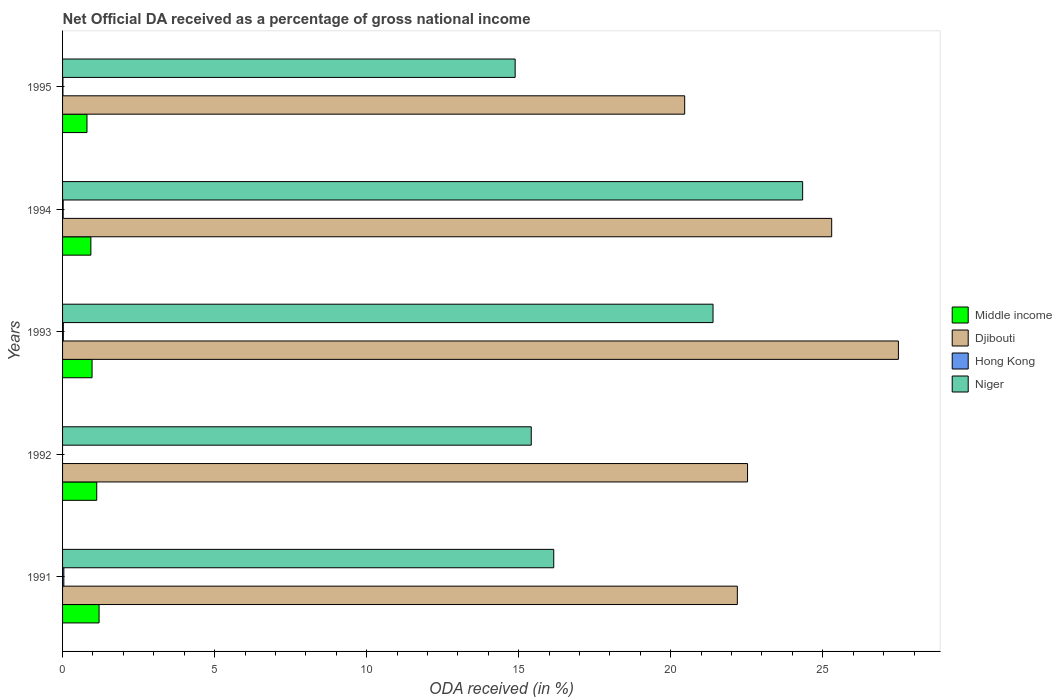How many different coloured bars are there?
Ensure brevity in your answer.  4. How many groups of bars are there?
Your response must be concise. 5. Are the number of bars per tick equal to the number of legend labels?
Provide a succinct answer. No. Are the number of bars on each tick of the Y-axis equal?
Your answer should be compact. No. How many bars are there on the 1st tick from the bottom?
Offer a very short reply. 4. In how many cases, is the number of bars for a given year not equal to the number of legend labels?
Make the answer very short. 1. What is the net official DA received in Middle income in 1993?
Provide a short and direct response. 0.97. Across all years, what is the maximum net official DA received in Djibouti?
Provide a succinct answer. 27.49. Across all years, what is the minimum net official DA received in Djibouti?
Keep it short and to the point. 20.46. What is the total net official DA received in Djibouti in the graph?
Keep it short and to the point. 117.95. What is the difference between the net official DA received in Hong Kong in 1994 and that in 1995?
Provide a succinct answer. 0.01. What is the difference between the net official DA received in Niger in 1992 and the net official DA received in Djibouti in 1991?
Your answer should be compact. -6.78. What is the average net official DA received in Niger per year?
Keep it short and to the point. 18.44. In the year 1995, what is the difference between the net official DA received in Niger and net official DA received in Djibouti?
Your answer should be compact. -5.58. In how many years, is the net official DA received in Niger greater than 5 %?
Your answer should be compact. 5. What is the ratio of the net official DA received in Hong Kong in 1993 to that in 1995?
Keep it short and to the point. 2.06. What is the difference between the highest and the second highest net official DA received in Djibouti?
Ensure brevity in your answer.  2.19. What is the difference between the highest and the lowest net official DA received in Middle income?
Your response must be concise. 0.4. In how many years, is the net official DA received in Niger greater than the average net official DA received in Niger taken over all years?
Give a very brief answer. 2. Is it the case that in every year, the sum of the net official DA received in Niger and net official DA received in Djibouti is greater than the sum of net official DA received in Middle income and net official DA received in Hong Kong?
Keep it short and to the point. No. What is the difference between two consecutive major ticks on the X-axis?
Keep it short and to the point. 5. Are the values on the major ticks of X-axis written in scientific E-notation?
Ensure brevity in your answer.  No. Does the graph contain grids?
Your response must be concise. No. Where does the legend appear in the graph?
Your response must be concise. Center right. How many legend labels are there?
Give a very brief answer. 4. What is the title of the graph?
Provide a short and direct response. Net Official DA received as a percentage of gross national income. What is the label or title of the X-axis?
Provide a short and direct response. ODA received (in %). What is the ODA received (in %) of Middle income in 1991?
Provide a succinct answer. 1.2. What is the ODA received (in %) of Djibouti in 1991?
Give a very brief answer. 22.19. What is the ODA received (in %) in Hong Kong in 1991?
Your response must be concise. 0.04. What is the ODA received (in %) of Niger in 1991?
Your answer should be compact. 16.15. What is the ODA received (in %) in Middle income in 1992?
Ensure brevity in your answer.  1.12. What is the ODA received (in %) of Djibouti in 1992?
Keep it short and to the point. 22.53. What is the ODA received (in %) in Hong Kong in 1992?
Provide a succinct answer. 0. What is the ODA received (in %) of Niger in 1992?
Ensure brevity in your answer.  15.41. What is the ODA received (in %) in Middle income in 1993?
Offer a very short reply. 0.97. What is the ODA received (in %) in Djibouti in 1993?
Offer a terse response. 27.49. What is the ODA received (in %) in Hong Kong in 1993?
Your answer should be compact. 0.03. What is the ODA received (in %) in Niger in 1993?
Provide a succinct answer. 21.39. What is the ODA received (in %) in Middle income in 1994?
Ensure brevity in your answer.  0.93. What is the ODA received (in %) in Djibouti in 1994?
Ensure brevity in your answer.  25.29. What is the ODA received (in %) of Hong Kong in 1994?
Give a very brief answer. 0.02. What is the ODA received (in %) of Niger in 1994?
Your answer should be compact. 24.34. What is the ODA received (in %) of Middle income in 1995?
Your answer should be compact. 0.8. What is the ODA received (in %) in Djibouti in 1995?
Offer a terse response. 20.46. What is the ODA received (in %) of Hong Kong in 1995?
Your answer should be compact. 0.01. What is the ODA received (in %) in Niger in 1995?
Keep it short and to the point. 14.88. Across all years, what is the maximum ODA received (in %) in Middle income?
Make the answer very short. 1.2. Across all years, what is the maximum ODA received (in %) of Djibouti?
Provide a short and direct response. 27.49. Across all years, what is the maximum ODA received (in %) of Hong Kong?
Your response must be concise. 0.04. Across all years, what is the maximum ODA received (in %) of Niger?
Provide a short and direct response. 24.34. Across all years, what is the minimum ODA received (in %) of Middle income?
Keep it short and to the point. 0.8. Across all years, what is the minimum ODA received (in %) in Djibouti?
Your answer should be compact. 20.46. Across all years, what is the minimum ODA received (in %) in Hong Kong?
Your answer should be very brief. 0. Across all years, what is the minimum ODA received (in %) in Niger?
Your answer should be compact. 14.88. What is the total ODA received (in %) in Middle income in the graph?
Keep it short and to the point. 5.03. What is the total ODA received (in %) in Djibouti in the graph?
Give a very brief answer. 117.95. What is the total ODA received (in %) of Hong Kong in the graph?
Ensure brevity in your answer.  0.1. What is the total ODA received (in %) in Niger in the graph?
Offer a terse response. 92.18. What is the difference between the ODA received (in %) of Middle income in 1991 and that in 1992?
Offer a very short reply. 0.08. What is the difference between the ODA received (in %) in Djibouti in 1991 and that in 1992?
Ensure brevity in your answer.  -0.34. What is the difference between the ODA received (in %) in Niger in 1991 and that in 1992?
Your answer should be very brief. 0.74. What is the difference between the ODA received (in %) in Middle income in 1991 and that in 1993?
Make the answer very short. 0.23. What is the difference between the ODA received (in %) of Djibouti in 1991 and that in 1993?
Keep it short and to the point. -5.3. What is the difference between the ODA received (in %) of Hong Kong in 1991 and that in 1993?
Ensure brevity in your answer.  0.02. What is the difference between the ODA received (in %) of Niger in 1991 and that in 1993?
Your answer should be compact. -5.24. What is the difference between the ODA received (in %) of Middle income in 1991 and that in 1994?
Offer a terse response. 0.27. What is the difference between the ODA received (in %) in Djibouti in 1991 and that in 1994?
Offer a terse response. -3.1. What is the difference between the ODA received (in %) in Hong Kong in 1991 and that in 1994?
Provide a succinct answer. 0.02. What is the difference between the ODA received (in %) in Niger in 1991 and that in 1994?
Your response must be concise. -8.18. What is the difference between the ODA received (in %) of Middle income in 1991 and that in 1995?
Your answer should be very brief. 0.4. What is the difference between the ODA received (in %) of Djibouti in 1991 and that in 1995?
Offer a very short reply. 1.73. What is the difference between the ODA received (in %) of Hong Kong in 1991 and that in 1995?
Provide a succinct answer. 0.03. What is the difference between the ODA received (in %) in Niger in 1991 and that in 1995?
Provide a succinct answer. 1.27. What is the difference between the ODA received (in %) in Middle income in 1992 and that in 1993?
Provide a succinct answer. 0.15. What is the difference between the ODA received (in %) in Djibouti in 1992 and that in 1993?
Offer a very short reply. -4.96. What is the difference between the ODA received (in %) of Niger in 1992 and that in 1993?
Make the answer very short. -5.98. What is the difference between the ODA received (in %) of Middle income in 1992 and that in 1994?
Your response must be concise. 0.19. What is the difference between the ODA received (in %) of Djibouti in 1992 and that in 1994?
Keep it short and to the point. -2.77. What is the difference between the ODA received (in %) in Niger in 1992 and that in 1994?
Offer a terse response. -8.92. What is the difference between the ODA received (in %) in Middle income in 1992 and that in 1995?
Give a very brief answer. 0.32. What is the difference between the ODA received (in %) in Djibouti in 1992 and that in 1995?
Provide a succinct answer. 2.07. What is the difference between the ODA received (in %) of Niger in 1992 and that in 1995?
Make the answer very short. 0.53. What is the difference between the ODA received (in %) in Middle income in 1993 and that in 1994?
Keep it short and to the point. 0.04. What is the difference between the ODA received (in %) of Djibouti in 1993 and that in 1994?
Ensure brevity in your answer.  2.19. What is the difference between the ODA received (in %) in Hong Kong in 1993 and that in 1994?
Ensure brevity in your answer.  0.01. What is the difference between the ODA received (in %) of Niger in 1993 and that in 1994?
Your answer should be compact. -2.95. What is the difference between the ODA received (in %) in Middle income in 1993 and that in 1995?
Provide a succinct answer. 0.17. What is the difference between the ODA received (in %) in Djibouti in 1993 and that in 1995?
Your answer should be very brief. 7.03. What is the difference between the ODA received (in %) of Hong Kong in 1993 and that in 1995?
Provide a succinct answer. 0.01. What is the difference between the ODA received (in %) in Niger in 1993 and that in 1995?
Your answer should be compact. 6.51. What is the difference between the ODA received (in %) in Middle income in 1994 and that in 1995?
Offer a terse response. 0.13. What is the difference between the ODA received (in %) of Djibouti in 1994 and that in 1995?
Give a very brief answer. 4.83. What is the difference between the ODA received (in %) of Hong Kong in 1994 and that in 1995?
Give a very brief answer. 0.01. What is the difference between the ODA received (in %) of Niger in 1994 and that in 1995?
Offer a very short reply. 9.45. What is the difference between the ODA received (in %) of Middle income in 1991 and the ODA received (in %) of Djibouti in 1992?
Your answer should be very brief. -21.33. What is the difference between the ODA received (in %) of Middle income in 1991 and the ODA received (in %) of Niger in 1992?
Your response must be concise. -14.21. What is the difference between the ODA received (in %) of Djibouti in 1991 and the ODA received (in %) of Niger in 1992?
Your answer should be compact. 6.78. What is the difference between the ODA received (in %) in Hong Kong in 1991 and the ODA received (in %) in Niger in 1992?
Give a very brief answer. -15.37. What is the difference between the ODA received (in %) of Middle income in 1991 and the ODA received (in %) of Djibouti in 1993?
Offer a very short reply. -26.29. What is the difference between the ODA received (in %) of Middle income in 1991 and the ODA received (in %) of Hong Kong in 1993?
Your response must be concise. 1.18. What is the difference between the ODA received (in %) of Middle income in 1991 and the ODA received (in %) of Niger in 1993?
Provide a succinct answer. -20.19. What is the difference between the ODA received (in %) in Djibouti in 1991 and the ODA received (in %) in Hong Kong in 1993?
Offer a terse response. 22.17. What is the difference between the ODA received (in %) of Djibouti in 1991 and the ODA received (in %) of Niger in 1993?
Your answer should be very brief. 0.8. What is the difference between the ODA received (in %) of Hong Kong in 1991 and the ODA received (in %) of Niger in 1993?
Give a very brief answer. -21.35. What is the difference between the ODA received (in %) in Middle income in 1991 and the ODA received (in %) in Djibouti in 1994?
Your response must be concise. -24.09. What is the difference between the ODA received (in %) of Middle income in 1991 and the ODA received (in %) of Hong Kong in 1994?
Make the answer very short. 1.18. What is the difference between the ODA received (in %) in Middle income in 1991 and the ODA received (in %) in Niger in 1994?
Make the answer very short. -23.14. What is the difference between the ODA received (in %) in Djibouti in 1991 and the ODA received (in %) in Hong Kong in 1994?
Your answer should be compact. 22.17. What is the difference between the ODA received (in %) of Djibouti in 1991 and the ODA received (in %) of Niger in 1994?
Provide a succinct answer. -2.15. What is the difference between the ODA received (in %) in Hong Kong in 1991 and the ODA received (in %) in Niger in 1994?
Ensure brevity in your answer.  -24.3. What is the difference between the ODA received (in %) in Middle income in 1991 and the ODA received (in %) in Djibouti in 1995?
Give a very brief answer. -19.26. What is the difference between the ODA received (in %) of Middle income in 1991 and the ODA received (in %) of Hong Kong in 1995?
Offer a terse response. 1.19. What is the difference between the ODA received (in %) of Middle income in 1991 and the ODA received (in %) of Niger in 1995?
Offer a terse response. -13.68. What is the difference between the ODA received (in %) in Djibouti in 1991 and the ODA received (in %) in Hong Kong in 1995?
Offer a very short reply. 22.18. What is the difference between the ODA received (in %) in Djibouti in 1991 and the ODA received (in %) in Niger in 1995?
Provide a short and direct response. 7.31. What is the difference between the ODA received (in %) in Hong Kong in 1991 and the ODA received (in %) in Niger in 1995?
Your answer should be compact. -14.84. What is the difference between the ODA received (in %) of Middle income in 1992 and the ODA received (in %) of Djibouti in 1993?
Make the answer very short. -26.36. What is the difference between the ODA received (in %) of Middle income in 1992 and the ODA received (in %) of Hong Kong in 1993?
Offer a terse response. 1.1. What is the difference between the ODA received (in %) of Middle income in 1992 and the ODA received (in %) of Niger in 1993?
Make the answer very short. -20.27. What is the difference between the ODA received (in %) in Djibouti in 1992 and the ODA received (in %) in Hong Kong in 1993?
Make the answer very short. 22.5. What is the difference between the ODA received (in %) in Djibouti in 1992 and the ODA received (in %) in Niger in 1993?
Provide a short and direct response. 1.14. What is the difference between the ODA received (in %) in Middle income in 1992 and the ODA received (in %) in Djibouti in 1994?
Your response must be concise. -24.17. What is the difference between the ODA received (in %) of Middle income in 1992 and the ODA received (in %) of Hong Kong in 1994?
Your answer should be compact. 1.1. What is the difference between the ODA received (in %) in Middle income in 1992 and the ODA received (in %) in Niger in 1994?
Your response must be concise. -23.21. What is the difference between the ODA received (in %) in Djibouti in 1992 and the ODA received (in %) in Hong Kong in 1994?
Provide a succinct answer. 22.51. What is the difference between the ODA received (in %) in Djibouti in 1992 and the ODA received (in %) in Niger in 1994?
Offer a very short reply. -1.81. What is the difference between the ODA received (in %) of Middle income in 1992 and the ODA received (in %) of Djibouti in 1995?
Offer a terse response. -19.34. What is the difference between the ODA received (in %) of Middle income in 1992 and the ODA received (in %) of Hong Kong in 1995?
Provide a succinct answer. 1.11. What is the difference between the ODA received (in %) of Middle income in 1992 and the ODA received (in %) of Niger in 1995?
Offer a terse response. -13.76. What is the difference between the ODA received (in %) of Djibouti in 1992 and the ODA received (in %) of Hong Kong in 1995?
Your answer should be compact. 22.51. What is the difference between the ODA received (in %) in Djibouti in 1992 and the ODA received (in %) in Niger in 1995?
Make the answer very short. 7.64. What is the difference between the ODA received (in %) of Middle income in 1993 and the ODA received (in %) of Djibouti in 1994?
Keep it short and to the point. -24.32. What is the difference between the ODA received (in %) of Middle income in 1993 and the ODA received (in %) of Hong Kong in 1994?
Your response must be concise. 0.95. What is the difference between the ODA received (in %) in Middle income in 1993 and the ODA received (in %) in Niger in 1994?
Your answer should be compact. -23.37. What is the difference between the ODA received (in %) in Djibouti in 1993 and the ODA received (in %) in Hong Kong in 1994?
Provide a short and direct response. 27.47. What is the difference between the ODA received (in %) of Djibouti in 1993 and the ODA received (in %) of Niger in 1994?
Give a very brief answer. 3.15. What is the difference between the ODA received (in %) of Hong Kong in 1993 and the ODA received (in %) of Niger in 1994?
Your answer should be very brief. -24.31. What is the difference between the ODA received (in %) in Middle income in 1993 and the ODA received (in %) in Djibouti in 1995?
Offer a terse response. -19.49. What is the difference between the ODA received (in %) of Middle income in 1993 and the ODA received (in %) of Hong Kong in 1995?
Your response must be concise. 0.96. What is the difference between the ODA received (in %) of Middle income in 1993 and the ODA received (in %) of Niger in 1995?
Offer a terse response. -13.91. What is the difference between the ODA received (in %) of Djibouti in 1993 and the ODA received (in %) of Hong Kong in 1995?
Provide a succinct answer. 27.47. What is the difference between the ODA received (in %) of Djibouti in 1993 and the ODA received (in %) of Niger in 1995?
Offer a terse response. 12.6. What is the difference between the ODA received (in %) in Hong Kong in 1993 and the ODA received (in %) in Niger in 1995?
Provide a short and direct response. -14.86. What is the difference between the ODA received (in %) of Middle income in 1994 and the ODA received (in %) of Djibouti in 1995?
Offer a very short reply. -19.53. What is the difference between the ODA received (in %) of Middle income in 1994 and the ODA received (in %) of Hong Kong in 1995?
Your answer should be very brief. 0.92. What is the difference between the ODA received (in %) in Middle income in 1994 and the ODA received (in %) in Niger in 1995?
Make the answer very short. -13.95. What is the difference between the ODA received (in %) in Djibouti in 1994 and the ODA received (in %) in Hong Kong in 1995?
Your answer should be compact. 25.28. What is the difference between the ODA received (in %) of Djibouti in 1994 and the ODA received (in %) of Niger in 1995?
Your response must be concise. 10.41. What is the difference between the ODA received (in %) of Hong Kong in 1994 and the ODA received (in %) of Niger in 1995?
Ensure brevity in your answer.  -14.86. What is the average ODA received (in %) in Djibouti per year?
Ensure brevity in your answer.  23.59. What is the average ODA received (in %) of Hong Kong per year?
Your answer should be very brief. 0.02. What is the average ODA received (in %) in Niger per year?
Your response must be concise. 18.44. In the year 1991, what is the difference between the ODA received (in %) of Middle income and ODA received (in %) of Djibouti?
Offer a terse response. -20.99. In the year 1991, what is the difference between the ODA received (in %) in Middle income and ODA received (in %) in Hong Kong?
Provide a succinct answer. 1.16. In the year 1991, what is the difference between the ODA received (in %) in Middle income and ODA received (in %) in Niger?
Your answer should be compact. -14.95. In the year 1991, what is the difference between the ODA received (in %) in Djibouti and ODA received (in %) in Hong Kong?
Keep it short and to the point. 22.15. In the year 1991, what is the difference between the ODA received (in %) of Djibouti and ODA received (in %) of Niger?
Keep it short and to the point. 6.04. In the year 1991, what is the difference between the ODA received (in %) in Hong Kong and ODA received (in %) in Niger?
Offer a terse response. -16.11. In the year 1992, what is the difference between the ODA received (in %) of Middle income and ODA received (in %) of Djibouti?
Your response must be concise. -21.4. In the year 1992, what is the difference between the ODA received (in %) in Middle income and ODA received (in %) in Niger?
Keep it short and to the point. -14.29. In the year 1992, what is the difference between the ODA received (in %) of Djibouti and ODA received (in %) of Niger?
Provide a succinct answer. 7.11. In the year 1993, what is the difference between the ODA received (in %) in Middle income and ODA received (in %) in Djibouti?
Make the answer very short. -26.52. In the year 1993, what is the difference between the ODA received (in %) in Middle income and ODA received (in %) in Hong Kong?
Keep it short and to the point. 0.95. In the year 1993, what is the difference between the ODA received (in %) in Middle income and ODA received (in %) in Niger?
Make the answer very short. -20.42. In the year 1993, what is the difference between the ODA received (in %) of Djibouti and ODA received (in %) of Hong Kong?
Keep it short and to the point. 27.46. In the year 1993, what is the difference between the ODA received (in %) of Djibouti and ODA received (in %) of Niger?
Ensure brevity in your answer.  6.1. In the year 1993, what is the difference between the ODA received (in %) in Hong Kong and ODA received (in %) in Niger?
Your response must be concise. -21.37. In the year 1994, what is the difference between the ODA received (in %) of Middle income and ODA received (in %) of Djibouti?
Offer a terse response. -24.36. In the year 1994, what is the difference between the ODA received (in %) in Middle income and ODA received (in %) in Hong Kong?
Provide a short and direct response. 0.91. In the year 1994, what is the difference between the ODA received (in %) in Middle income and ODA received (in %) in Niger?
Keep it short and to the point. -23.41. In the year 1994, what is the difference between the ODA received (in %) in Djibouti and ODA received (in %) in Hong Kong?
Ensure brevity in your answer.  25.27. In the year 1994, what is the difference between the ODA received (in %) in Djibouti and ODA received (in %) in Niger?
Provide a short and direct response. 0.96. In the year 1994, what is the difference between the ODA received (in %) of Hong Kong and ODA received (in %) of Niger?
Provide a succinct answer. -24.32. In the year 1995, what is the difference between the ODA received (in %) in Middle income and ODA received (in %) in Djibouti?
Make the answer very short. -19.66. In the year 1995, what is the difference between the ODA received (in %) of Middle income and ODA received (in %) of Hong Kong?
Your answer should be compact. 0.79. In the year 1995, what is the difference between the ODA received (in %) of Middle income and ODA received (in %) of Niger?
Your answer should be very brief. -14.08. In the year 1995, what is the difference between the ODA received (in %) of Djibouti and ODA received (in %) of Hong Kong?
Keep it short and to the point. 20.45. In the year 1995, what is the difference between the ODA received (in %) of Djibouti and ODA received (in %) of Niger?
Make the answer very short. 5.58. In the year 1995, what is the difference between the ODA received (in %) of Hong Kong and ODA received (in %) of Niger?
Ensure brevity in your answer.  -14.87. What is the ratio of the ODA received (in %) in Middle income in 1991 to that in 1992?
Keep it short and to the point. 1.07. What is the ratio of the ODA received (in %) of Djibouti in 1991 to that in 1992?
Your answer should be very brief. 0.99. What is the ratio of the ODA received (in %) in Niger in 1991 to that in 1992?
Your response must be concise. 1.05. What is the ratio of the ODA received (in %) in Middle income in 1991 to that in 1993?
Keep it short and to the point. 1.24. What is the ratio of the ODA received (in %) in Djibouti in 1991 to that in 1993?
Your response must be concise. 0.81. What is the ratio of the ODA received (in %) in Hong Kong in 1991 to that in 1993?
Provide a short and direct response. 1.67. What is the ratio of the ODA received (in %) in Niger in 1991 to that in 1993?
Offer a terse response. 0.76. What is the ratio of the ODA received (in %) of Middle income in 1991 to that in 1994?
Keep it short and to the point. 1.29. What is the ratio of the ODA received (in %) of Djibouti in 1991 to that in 1994?
Your response must be concise. 0.88. What is the ratio of the ODA received (in %) in Hong Kong in 1991 to that in 1994?
Offer a very short reply. 2.12. What is the ratio of the ODA received (in %) of Niger in 1991 to that in 1994?
Give a very brief answer. 0.66. What is the ratio of the ODA received (in %) of Middle income in 1991 to that in 1995?
Your answer should be compact. 1.49. What is the ratio of the ODA received (in %) in Djibouti in 1991 to that in 1995?
Your answer should be compact. 1.08. What is the ratio of the ODA received (in %) in Hong Kong in 1991 to that in 1995?
Make the answer very short. 3.44. What is the ratio of the ODA received (in %) in Niger in 1991 to that in 1995?
Your answer should be compact. 1.09. What is the ratio of the ODA received (in %) in Middle income in 1992 to that in 1993?
Your answer should be very brief. 1.16. What is the ratio of the ODA received (in %) in Djibouti in 1992 to that in 1993?
Offer a very short reply. 0.82. What is the ratio of the ODA received (in %) of Niger in 1992 to that in 1993?
Provide a short and direct response. 0.72. What is the ratio of the ODA received (in %) in Middle income in 1992 to that in 1994?
Your answer should be very brief. 1.21. What is the ratio of the ODA received (in %) of Djibouti in 1992 to that in 1994?
Offer a terse response. 0.89. What is the ratio of the ODA received (in %) of Niger in 1992 to that in 1994?
Ensure brevity in your answer.  0.63. What is the ratio of the ODA received (in %) of Middle income in 1992 to that in 1995?
Your answer should be very brief. 1.4. What is the ratio of the ODA received (in %) of Djibouti in 1992 to that in 1995?
Give a very brief answer. 1.1. What is the ratio of the ODA received (in %) of Niger in 1992 to that in 1995?
Ensure brevity in your answer.  1.04. What is the ratio of the ODA received (in %) of Middle income in 1993 to that in 1994?
Your answer should be very brief. 1.04. What is the ratio of the ODA received (in %) in Djibouti in 1993 to that in 1994?
Provide a succinct answer. 1.09. What is the ratio of the ODA received (in %) of Hong Kong in 1993 to that in 1994?
Your answer should be very brief. 1.27. What is the ratio of the ODA received (in %) of Niger in 1993 to that in 1994?
Give a very brief answer. 0.88. What is the ratio of the ODA received (in %) in Middle income in 1993 to that in 1995?
Your answer should be compact. 1.21. What is the ratio of the ODA received (in %) of Djibouti in 1993 to that in 1995?
Keep it short and to the point. 1.34. What is the ratio of the ODA received (in %) of Hong Kong in 1993 to that in 1995?
Offer a terse response. 2.06. What is the ratio of the ODA received (in %) of Niger in 1993 to that in 1995?
Provide a succinct answer. 1.44. What is the ratio of the ODA received (in %) in Middle income in 1994 to that in 1995?
Make the answer very short. 1.16. What is the ratio of the ODA received (in %) in Djibouti in 1994 to that in 1995?
Offer a very short reply. 1.24. What is the ratio of the ODA received (in %) of Hong Kong in 1994 to that in 1995?
Make the answer very short. 1.62. What is the ratio of the ODA received (in %) of Niger in 1994 to that in 1995?
Make the answer very short. 1.64. What is the difference between the highest and the second highest ODA received (in %) in Middle income?
Provide a short and direct response. 0.08. What is the difference between the highest and the second highest ODA received (in %) of Djibouti?
Your answer should be very brief. 2.19. What is the difference between the highest and the second highest ODA received (in %) in Hong Kong?
Provide a succinct answer. 0.02. What is the difference between the highest and the second highest ODA received (in %) of Niger?
Give a very brief answer. 2.95. What is the difference between the highest and the lowest ODA received (in %) of Middle income?
Your answer should be very brief. 0.4. What is the difference between the highest and the lowest ODA received (in %) of Djibouti?
Your answer should be compact. 7.03. What is the difference between the highest and the lowest ODA received (in %) of Hong Kong?
Provide a succinct answer. 0.04. What is the difference between the highest and the lowest ODA received (in %) of Niger?
Make the answer very short. 9.45. 